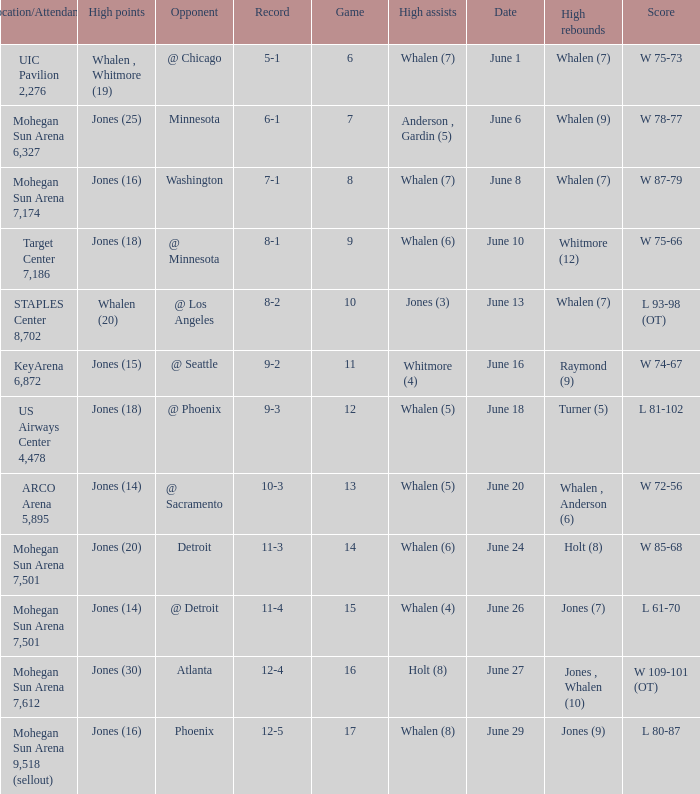Who had the high assists when the game was less than 13 and the score was w 75-66? Whalen (6). 